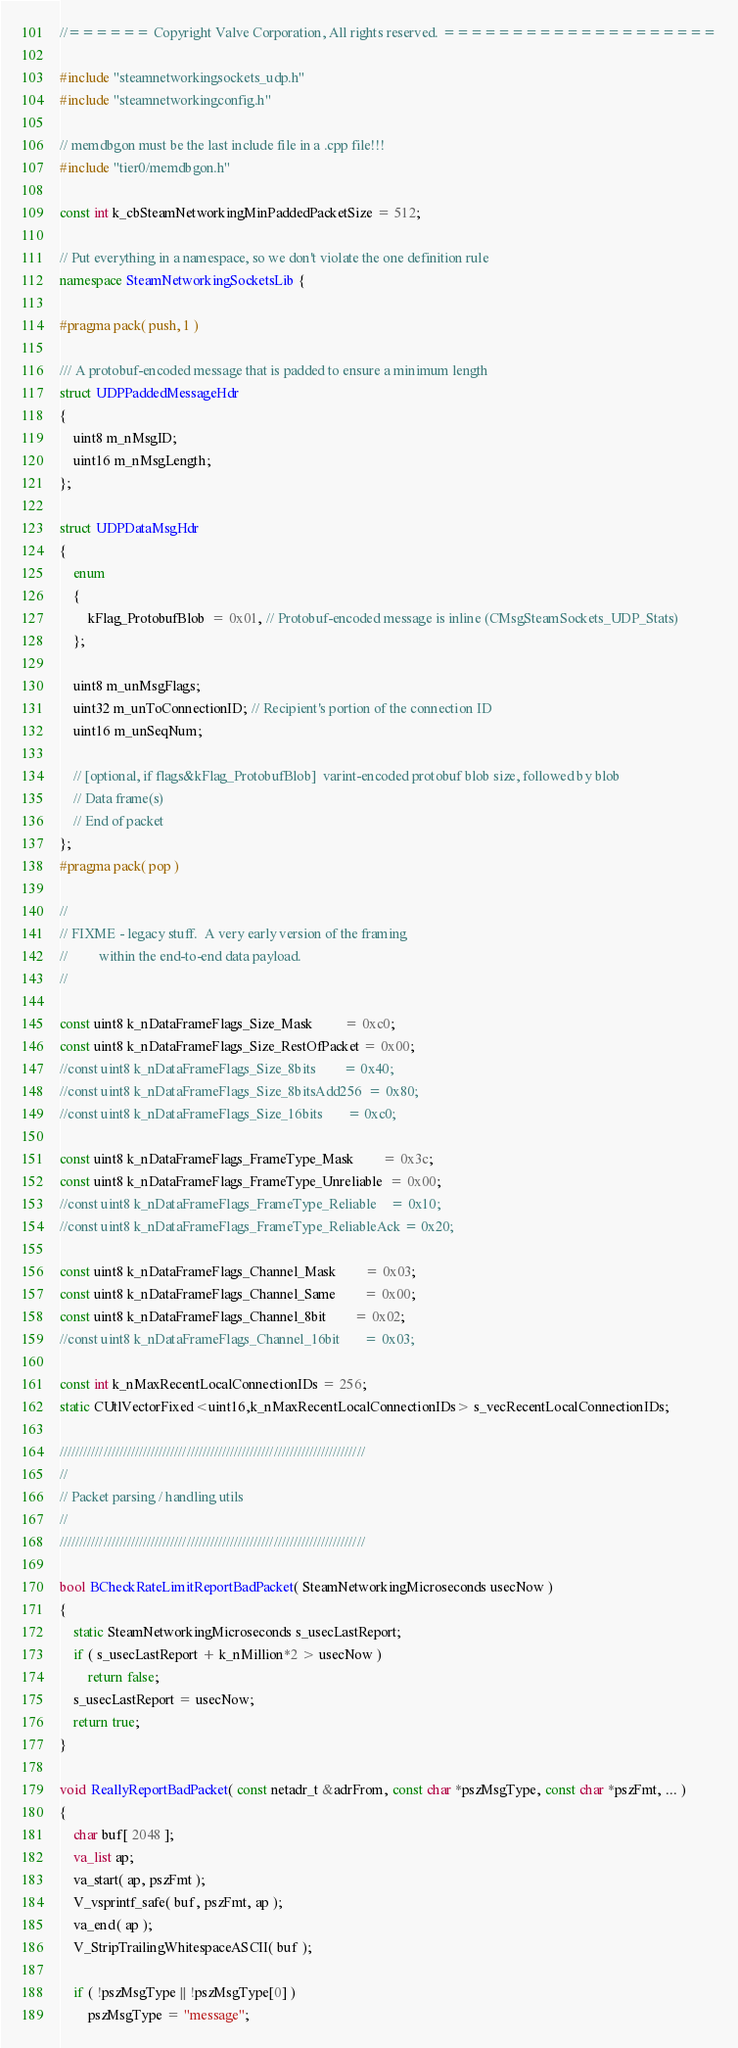Convert code to text. <code><loc_0><loc_0><loc_500><loc_500><_C++_>//====== Copyright Valve Corporation, All rights reserved. ====================

#include "steamnetworkingsockets_udp.h"
#include "steamnetworkingconfig.h"

// memdbgon must be the last include file in a .cpp file!!!
#include "tier0/memdbgon.h"

const int k_cbSteamNetworkingMinPaddedPacketSize = 512;

// Put everything in a namespace, so we don't violate the one definition rule
namespace SteamNetworkingSocketsLib {

#pragma pack( push, 1 )

/// A protobuf-encoded message that is padded to ensure a minimum length
struct UDPPaddedMessageHdr
{
	uint8 m_nMsgID;
	uint16 m_nMsgLength;
};

struct UDPDataMsgHdr
{
	enum
	{
		kFlag_ProtobufBlob  = 0x01, // Protobuf-encoded message is inline (CMsgSteamSockets_UDP_Stats)
	};

	uint8 m_unMsgFlags;
	uint32 m_unToConnectionID; // Recipient's portion of the connection ID
	uint16 m_unSeqNum;

	// [optional, if flags&kFlag_ProtobufBlob]  varint-encoded protobuf blob size, followed by blob
	// Data frame(s)
	// End of packet
};
#pragma pack( pop )

//
// FIXME - legacy stuff.  A very early version of the framing
//         within the end-to-end data payload.
//

const uint8 k_nDataFrameFlags_Size_Mask         = 0xc0;
const uint8 k_nDataFrameFlags_Size_RestOfPacket = 0x00;
//const uint8 k_nDataFrameFlags_Size_8bits        = 0x40;
//const uint8 k_nDataFrameFlags_Size_8bitsAdd256  = 0x80;
//const uint8 k_nDataFrameFlags_Size_16bits       = 0xc0;

const uint8 k_nDataFrameFlags_FrameType_Mask        = 0x3c;
const uint8 k_nDataFrameFlags_FrameType_Unreliable  = 0x00;
//const uint8 k_nDataFrameFlags_FrameType_Reliable    = 0x10;
//const uint8 k_nDataFrameFlags_FrameType_ReliableAck = 0x20;

const uint8 k_nDataFrameFlags_Channel_Mask        = 0x03;
const uint8 k_nDataFrameFlags_Channel_Same        = 0x00;
const uint8 k_nDataFrameFlags_Channel_8bit        = 0x02;
//const uint8 k_nDataFrameFlags_Channel_16bit       = 0x03;

const int k_nMaxRecentLocalConnectionIDs = 256;
static CUtlVectorFixed<uint16,k_nMaxRecentLocalConnectionIDs> s_vecRecentLocalConnectionIDs;

/////////////////////////////////////////////////////////////////////////////
//
// Packet parsing / handling utils
//
/////////////////////////////////////////////////////////////////////////////

bool BCheckRateLimitReportBadPacket( SteamNetworkingMicroseconds usecNow )
{
	static SteamNetworkingMicroseconds s_usecLastReport;
	if ( s_usecLastReport + k_nMillion*2 > usecNow )
		return false;
	s_usecLastReport = usecNow;
	return true;
}

void ReallyReportBadPacket( const netadr_t &adrFrom, const char *pszMsgType, const char *pszFmt, ... )
{
	char buf[ 2048 ];
	va_list ap;
	va_start( ap, pszFmt );
	V_vsprintf_safe( buf, pszFmt, ap );
	va_end( ap );
	V_StripTrailingWhitespaceASCII( buf );

	if ( !pszMsgType || !pszMsgType[0] )
		pszMsgType = "message";
</code> 